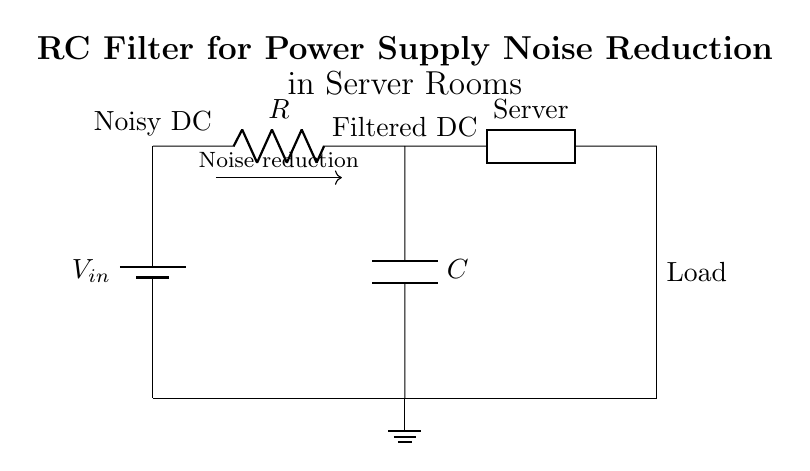What is the input voltage of this circuit? The input voltage is represented as V in the circuit diagram, which is identified as the voltage source connected at the top left.
Answer: V in What components are present in this RC filter? The circuit contains two components: a resistor labeled R and a capacitor labeled C, which are connected in series to form the RC filter.
Answer: R, C How does the RC filter affect the noise? The circuit diagram indicates that the RC filter reduces noise, evident from the labeled arrow stating "Noise reduction" along the path between V in and the filtered output.
Answer: Noise reduction What type of load is connected to this circuit? The load connected at the right side is labeled "Server," indicating that it is a generic load, likely representative of a server in a data center context.
Answer: Server What is the output voltage after filtering? The filtered voltage is labeled as "Filtered DC," indicating that it is the voltage resulting after the RC filter processes the input voltage, V in.
Answer: Filtered DC What is the main function of the capacitor in this circuit? The capacitor in this RC filter acts to smooth out the voltage fluctuations caused by noise in the power supply, helping to stabilize the output voltage for the connected load.
Answer: Voltage stabilization Which component is primarily responsible for the time constant of the circuit? The resistor R and the capacitor C together determine the time constant of the circuit, expressed as τ = R * C, which defines how quickly the circuit responds to changes in voltage.
Answer: R, C 